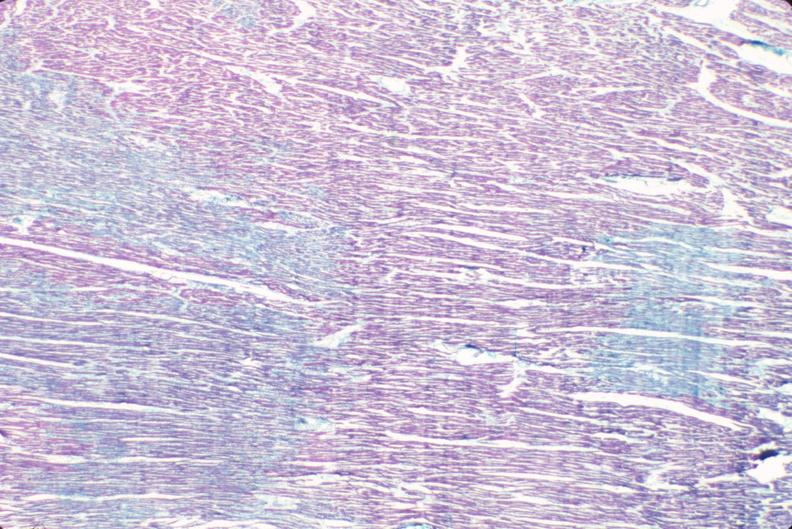do aldehyde fuscin stain?
Answer the question using a single word or phrase. Yes 